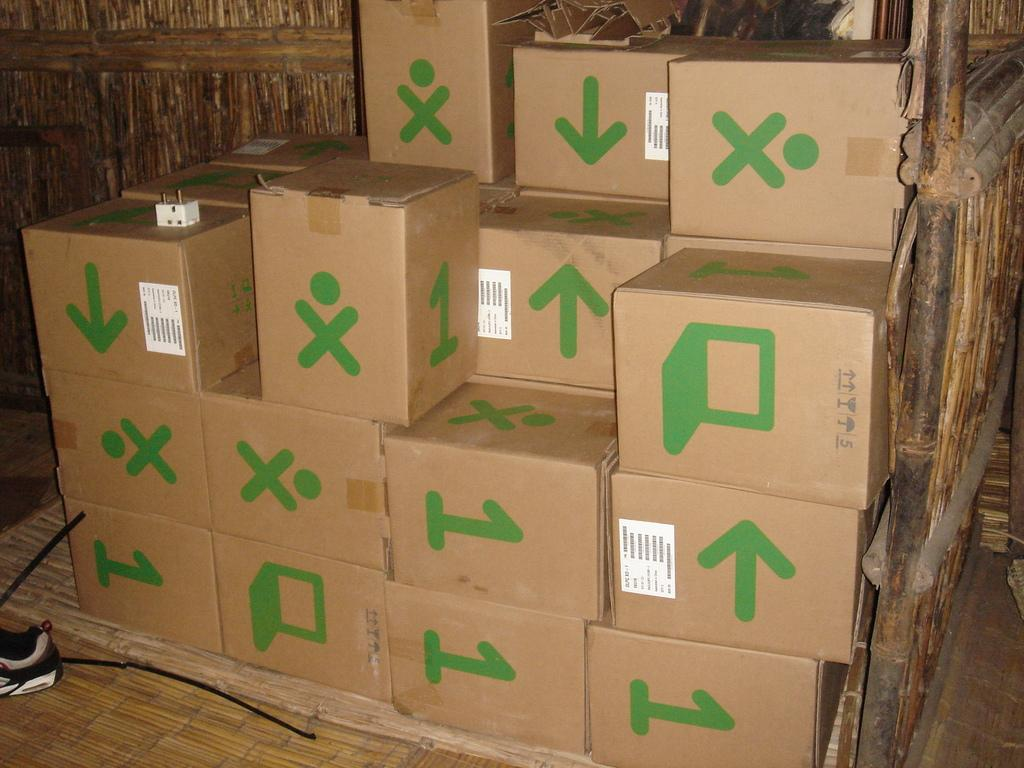What objects are on the floor in the image? There are boxes and a shoe on the floor in the image. What can be seen in the background of the image? There are wood logs in the background of the image. What type of effect does the goose have on the boxes in the image? There is no goose present in the image, so it cannot have any effect on the boxes. 